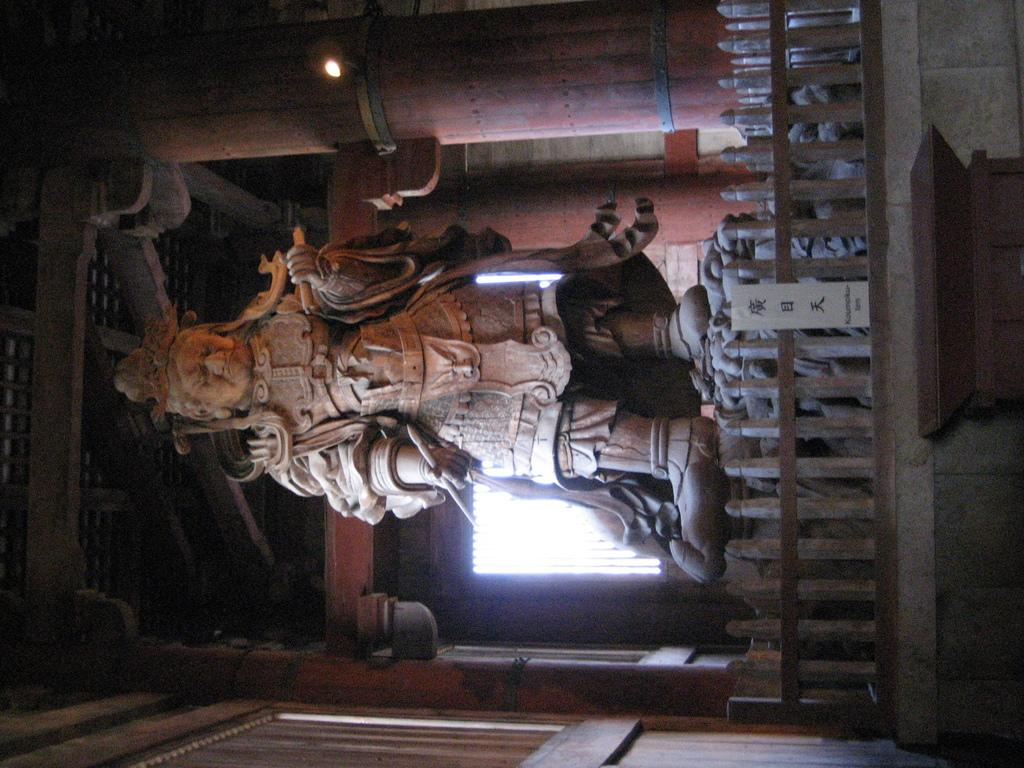What is the main structure in the image? There is a statue in the image. What architectural features can be seen in the image? There are pillars, a fence, a window, and a roof in the image. What type of riddle is being solved by the statue in the image? There is no riddle being solved by the statue in the image; it is a stationary structure. 